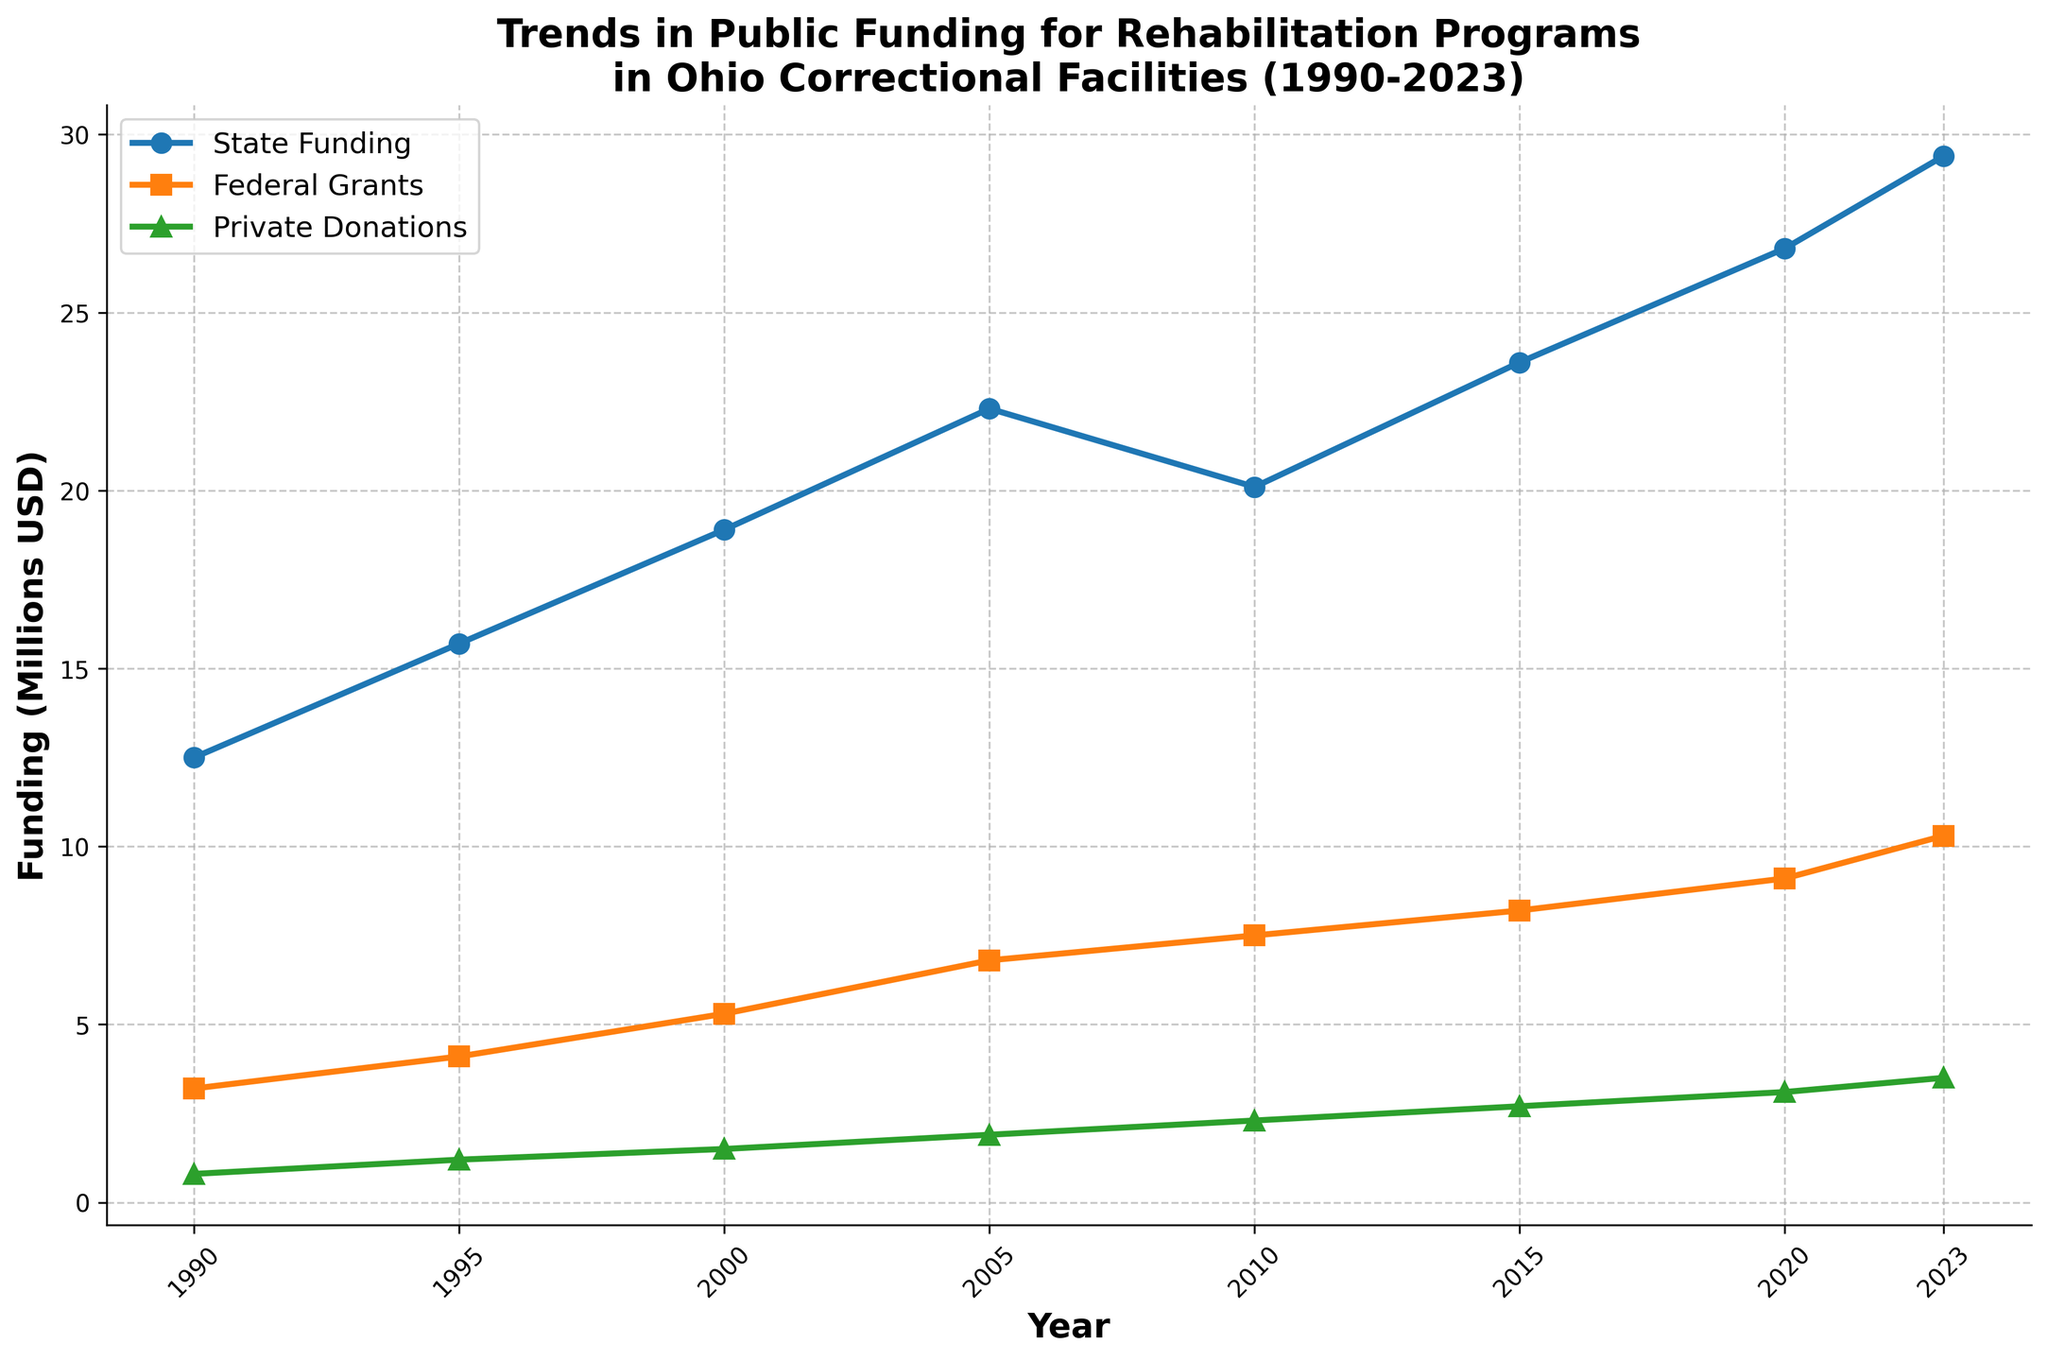How have state funding amounts changed from 1990 to 2023? To determine the change, subtract the state funding in 1990 from the state funding in 2023. The amounts are 29.4 (2023) and 12.5 (1990). The change equals 29.4 - 12.5 = 16.9 million USD.
Answer: 16.9 million USD Which type of funding saw the greatest increase between 1990 and 2023? Calculate the increases for each type of funding by subtracting the 1990 amounts from the 2023 amounts. State Funding: 29.4 - 12.5 = 16.9 million USD, Federal Grants: 10.3 - 3.2 = 7.1 million USD, Private Donations: 3.5 - 0.8 = 2.7 million USD. The greatest increase is in State Funding.
Answer: State Funding In which year did federal grants surpass $7 million? By examining the graph, Federal Grants surpassed $7 million in 2005.
Answer: 2005 How much more funding did state funding receive in 2023 compared to federal grants in 2005? Identify amounts: State Funding in 2023 is 29.4 million USD and Federal Grants in 2005 is 6.8 million USD. Calculate the difference: 29.4 - 6.8 = 22.6 million USD.
Answer: 22.6 million USD Which year saw the closest funding amounts between federal grants and private donations? By visual inspection, the closest funding amounts appear around 1995, where Federal Grants were 4.1 million USD and Private Donations were 1.2 million USD.
Answer: 1995 In what year did private donations first exceed 2 million USD? Use the graph to find that private donations first exceeded 2 million USD in 2010.
Answer: 2010 Comparing 1990 and 2023, in which category did funding increase at the slowest rate? Calculate the increase for each category from 1990 to 2023. State Funding: 29.4 - 12.5 = 16.9 million USD, Federal Grants: 10.3 - 3.2 = 7.1 million USD, Private Donations: 3.5 - 0.8 = 2.7 million USD. The slowest increase is in Private Donations.
Answer: Private Donations How much total funding was there in 2020 across all categories? Add the amounts for 2020: State Funding (26.8 million), Federal Grants (9.1 million), and Private Donations (3.1 million). Total = 26.8 + 9.1 + 3.1 = 39 million USD.
Answer: 39 million USD By how much did federal grants grow from 1990 to 2005? Subtract the federal grants in 1990 from those in 2005. Federal Grants in 1990: 3.2 million USD, in 2005: 6.8 million USD. Difference: 6.8 - 3.2 = 3.6 million USD.
Answer: 3.6 million USD Which funding source had a consistent increase each period from 1990 to 2023? By visually inspecting the graph, Federal Grants consistently increased every recorded period.
Answer: Federal Grants 